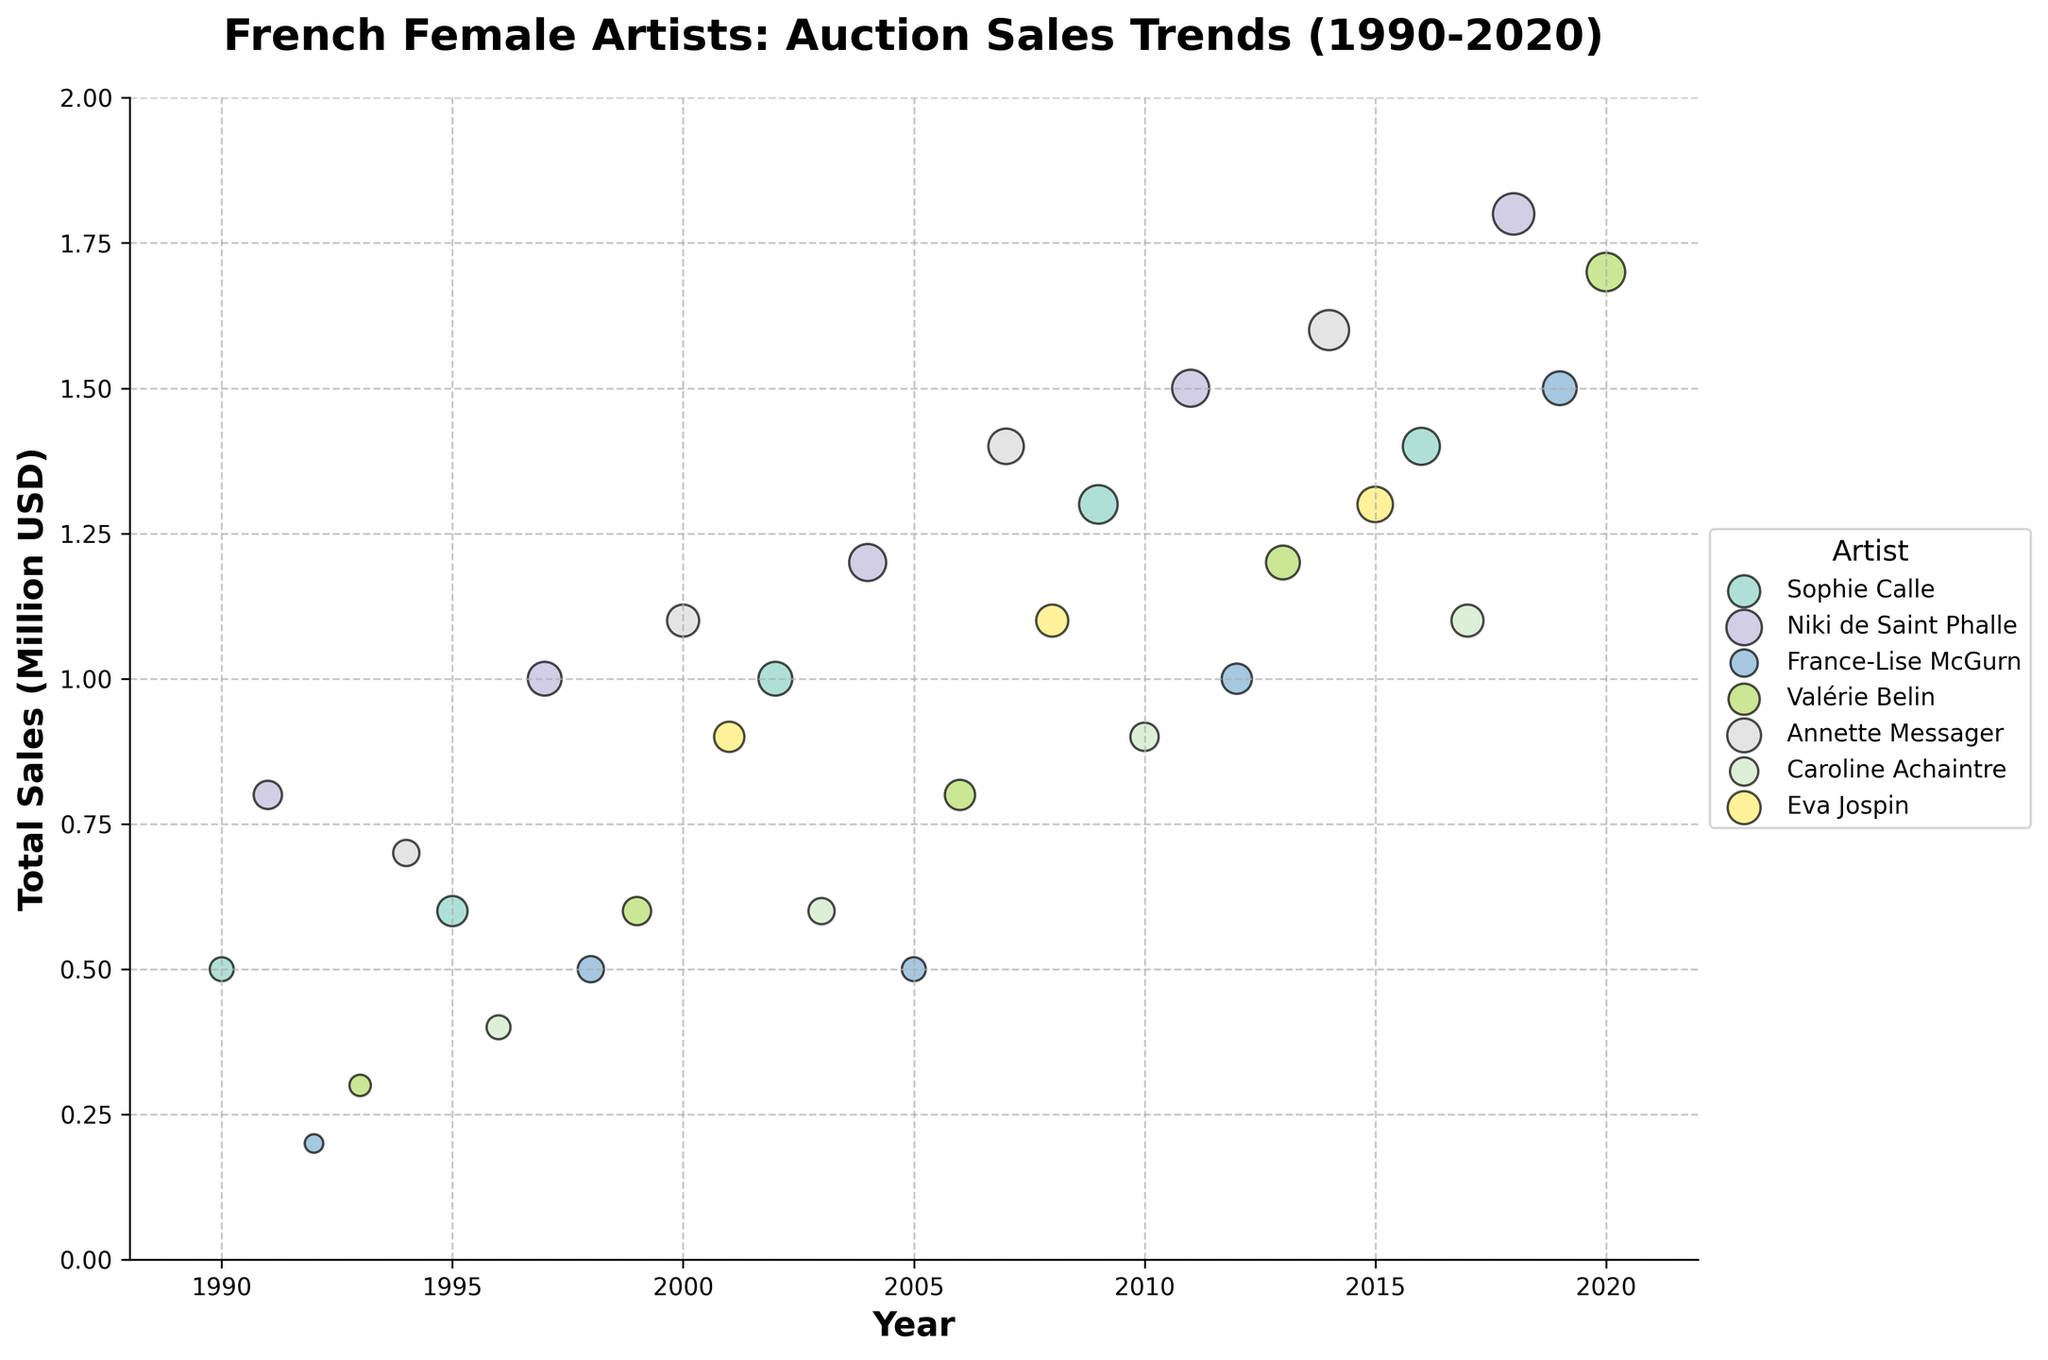What is the title of the figure? The title of the figure can be found at the top of the plot. It summarizes what the plot is about.
Answer: French Female Artists: Auction Sales Trends (1990-2020) Which artist had the highest total sales in 2018? Look at the data points for the year 2018 and check which artist's data point is highest on the y-axis.
Answer: Niki de Saint Phalle Which artist had the greatest number of works sold in 1997? The size of the data points represents the number of works sold. Look at the year 1997 and find the largest data point.
Answer: Niki de Saint Phalle What was the total sales in 2014 for Annette Messager? Locate the data point for Annette Messager in the year 2014 and read the corresponding y-axis value.
Answer: 1.6 million USD How many works did Eva Jospin sell in 2008? The size of the data points indicates the number of works sold. Look for Eva Jospin's data point in 2008 and check the size.
Answer: 9 works Compare Sophie Calle's total sales in 2009 and 2016. Which year had higher sales? Identify Sophie Calle's data points for 2009 and 2016 and compare their y-axis values.
Answer: 2016 Which artist sold the most works in total across all the years? Sum up the sizes (number of works sold) of all data points for each artist and find the highest. Detailed explanation: Sum up as follows: 
Sophie Calle: 5+8+10+13+12 = 48,
Niki de Saint Phalle: 7+10+12+15 = 44,
France-Lise McGurn: 3+6+5+8+10 = 32,
Valérie Belin: 4+7+8+10+13 = 42,
Annette Messager: 6+9+11+14 = 40,
Caroline Achaintre: 5+6+7+9 = 27,
Eva Jospin: 8+9+11 = 28 
The highest total is for Sophie Calle.
Answer: Sophie Calle What is the average total sales in 2020 for Valérie Belin? Locate the total sales for Valérie Belin in 2020 and calculate the average. Since it's only a single data point for a unique year, the average is the same as that value.
Answer: 1.7 million USD Between 2004 and 2008, which artist showed an increasing trend in the total sales? Check the data points for each artist between 2004 and 2008 and identify if the data points are ascending.
Answer: Eva Jospin How does the auction sales trend for Niki de Saint Phalle change from 1991 to 2018? Look at Niki de Saint Phalle's data points from 1991, 1997, 2004, 2011, and 2018 and describe the changes in y-values (total sales).
Answer: Increasing 